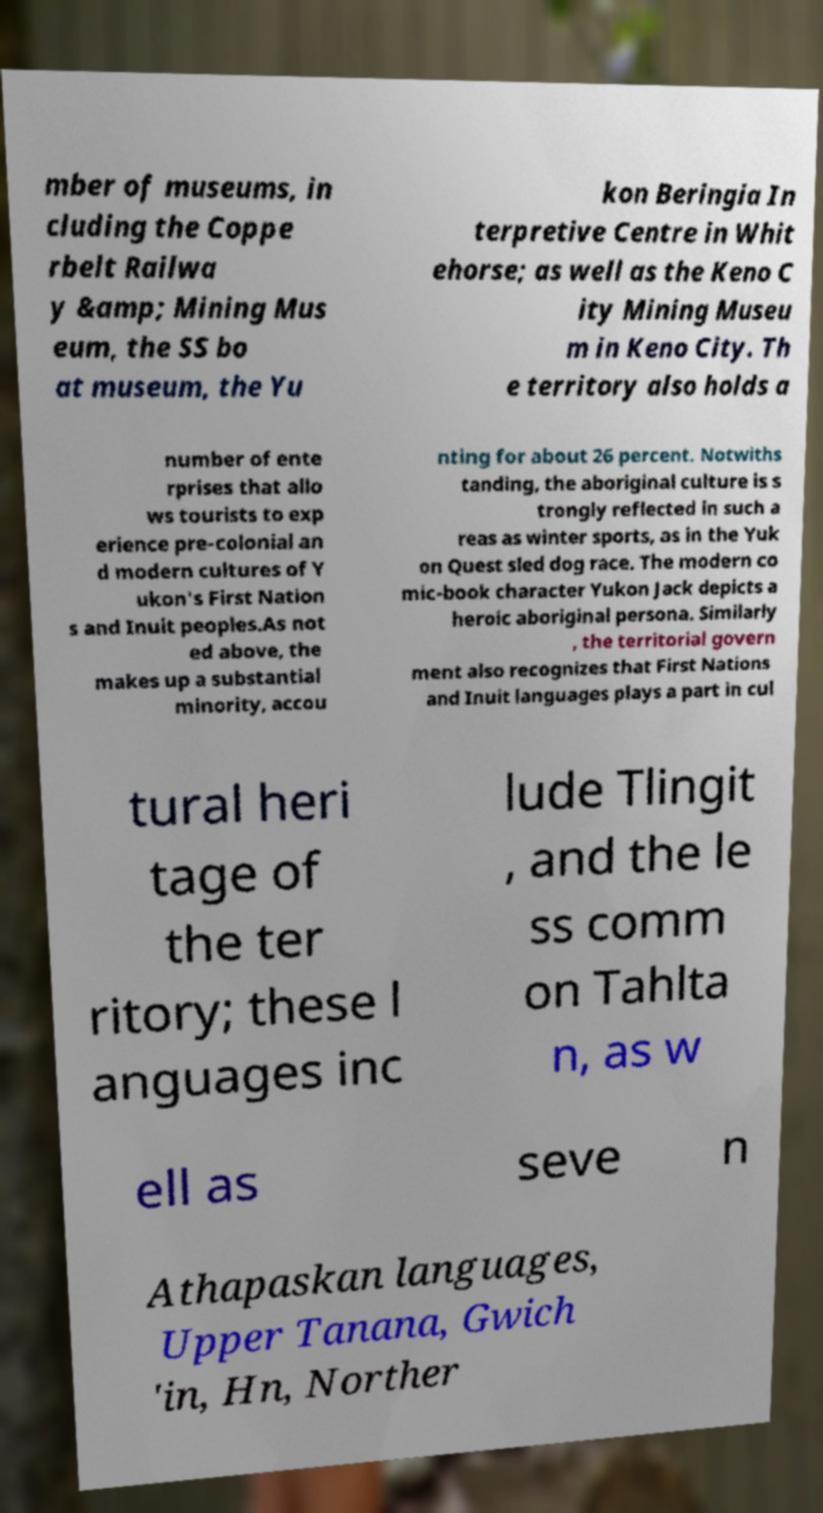Can you accurately transcribe the text from the provided image for me? mber of museums, in cluding the Coppe rbelt Railwa y &amp; Mining Mus eum, the SS bo at museum, the Yu kon Beringia In terpretive Centre in Whit ehorse; as well as the Keno C ity Mining Museu m in Keno City. Th e territory also holds a number of ente rprises that allo ws tourists to exp erience pre-colonial an d modern cultures of Y ukon's First Nation s and Inuit peoples.As not ed above, the makes up a substantial minority, accou nting for about 26 percent. Notwiths tanding, the aboriginal culture is s trongly reflected in such a reas as winter sports, as in the Yuk on Quest sled dog race. The modern co mic-book character Yukon Jack depicts a heroic aboriginal persona. Similarly , the territorial govern ment also recognizes that First Nations and Inuit languages plays a part in cul tural heri tage of the ter ritory; these l anguages inc lude Tlingit , and the le ss comm on Tahlta n, as w ell as seve n Athapaskan languages, Upper Tanana, Gwich 'in, Hn, Norther 